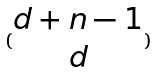Convert formula to latex. <formula><loc_0><loc_0><loc_500><loc_500>( \begin{matrix} d + n - 1 \\ d \end{matrix} )</formula> 